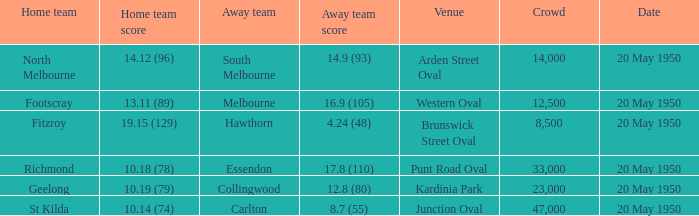What was the score for the visiting team that competed against richmond and had an audience of more than 12,500? 17.8 (110). 